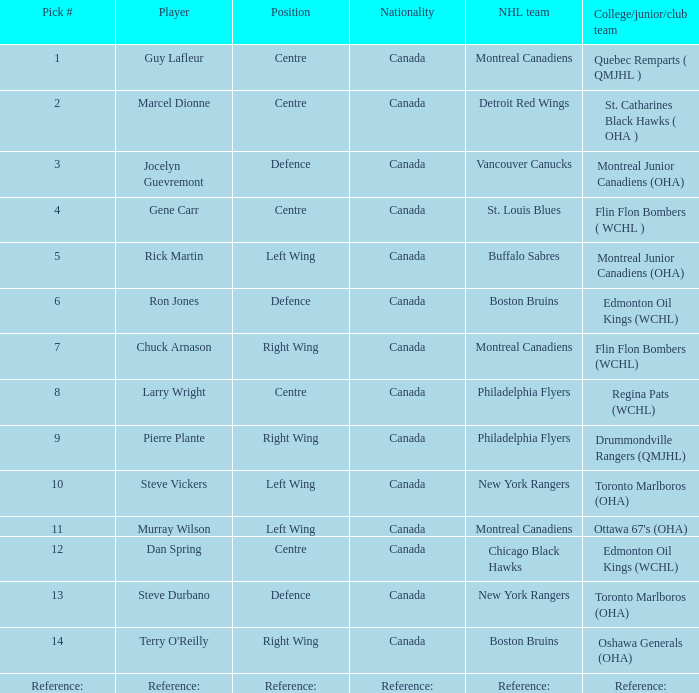Which team from college, junior, or club level holds the first pick? Quebec Remparts ( QMJHL ). 